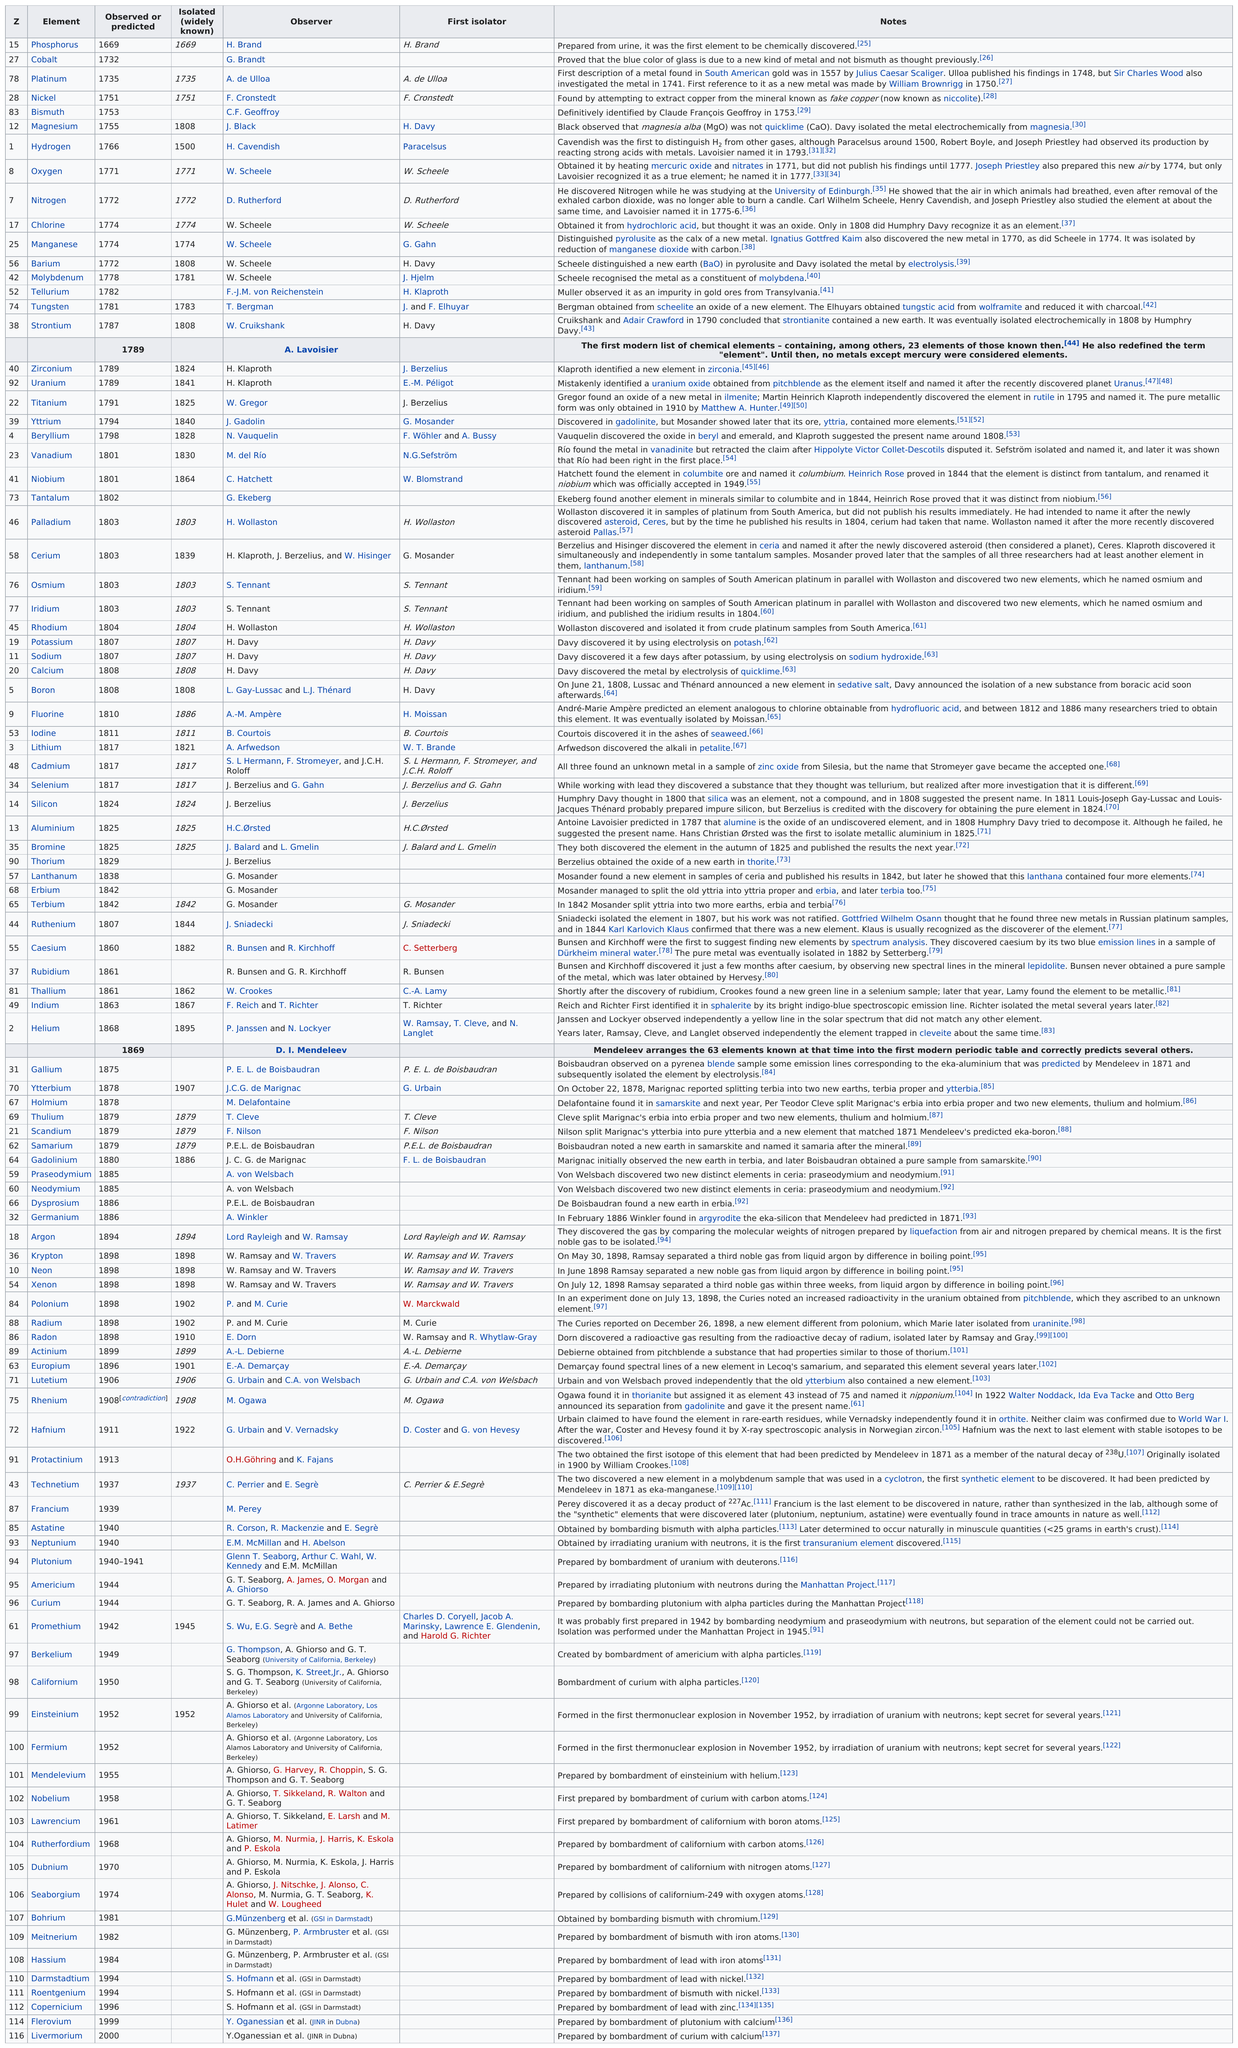Mention a couple of crucial points in this snapshot. In 1771, William Scheele discovered and observed oxygen, which is an element that is essential for life on Earth. 